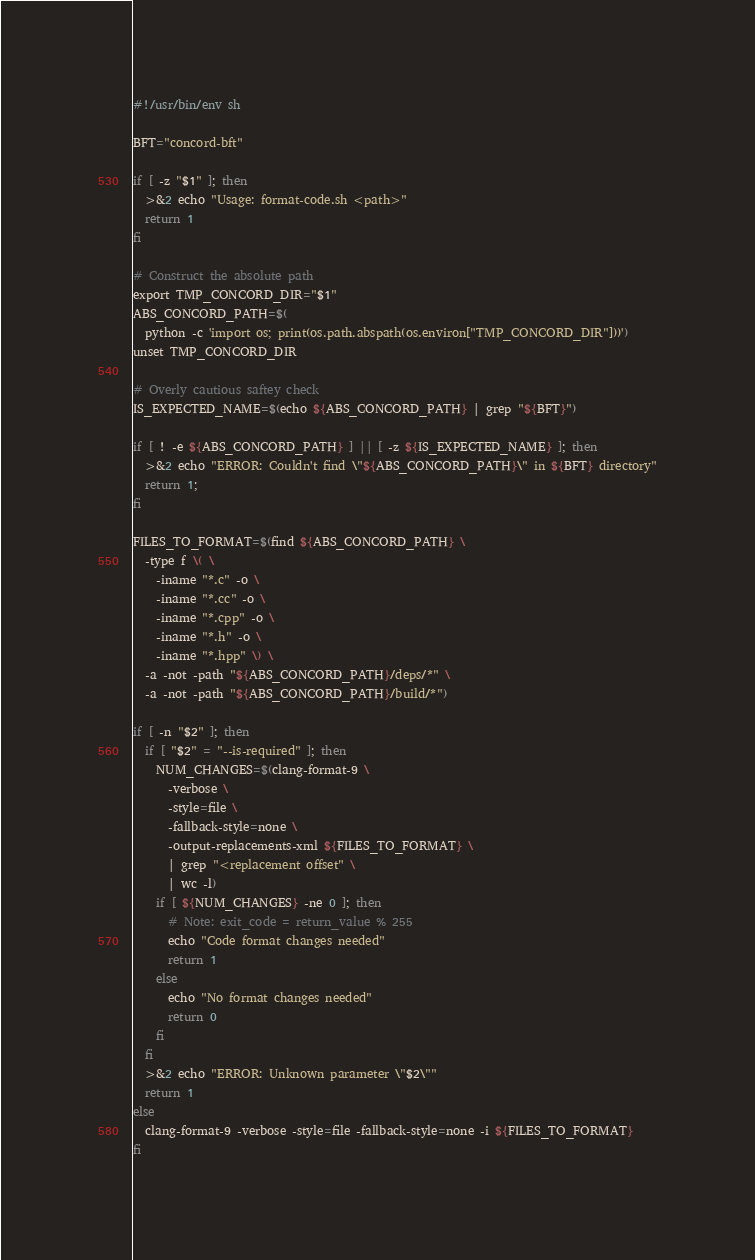<code> <loc_0><loc_0><loc_500><loc_500><_Bash_>#!/usr/bin/env sh

BFT="concord-bft"

if [ -z "$1" ]; then
  >&2 echo "Usage: format-code.sh <path>"
  return 1
fi

# Construct the absolute path
export TMP_CONCORD_DIR="$1"
ABS_CONCORD_PATH=$(
  python -c 'import os; print(os.path.abspath(os.environ["TMP_CONCORD_DIR"]))')
unset TMP_CONCORD_DIR

# Overly cautious saftey check
IS_EXPECTED_NAME=$(echo ${ABS_CONCORD_PATH} | grep "${BFT}")

if [ ! -e ${ABS_CONCORD_PATH} ] || [ -z ${IS_EXPECTED_NAME} ]; then
  >&2 echo "ERROR: Couldn't find \"${ABS_CONCORD_PATH}\" in ${BFT} directory"
  return 1;
fi

FILES_TO_FORMAT=$(find ${ABS_CONCORD_PATH} \
  -type f \( \
    -iname "*.c" -o \
    -iname "*.cc" -o \
    -iname "*.cpp" -o \
    -iname "*.h" -o \
    -iname "*.hpp" \) \
  -a -not -path "${ABS_CONCORD_PATH}/deps/*" \
  -a -not -path "${ABS_CONCORD_PATH}/build/*")

if [ -n "$2" ]; then
  if [ "$2" = "--is-required" ]; then
    NUM_CHANGES=$(clang-format-9 \
      -verbose \
      -style=file \
      -fallback-style=none \
      -output-replacements-xml ${FILES_TO_FORMAT} \
      | grep "<replacement offset" \
      | wc -l)
    if [ ${NUM_CHANGES} -ne 0 ]; then
      # Note: exit_code = return_value % 255
      echo "Code format changes needed"
      return 1
    else
      echo "No format changes needed"
      return 0
    fi
  fi
  >&2 echo "ERROR: Unknown parameter \"$2\""
  return 1
else
  clang-format-9 -verbose -style=file -fallback-style=none -i ${FILES_TO_FORMAT}
fi
</code> 